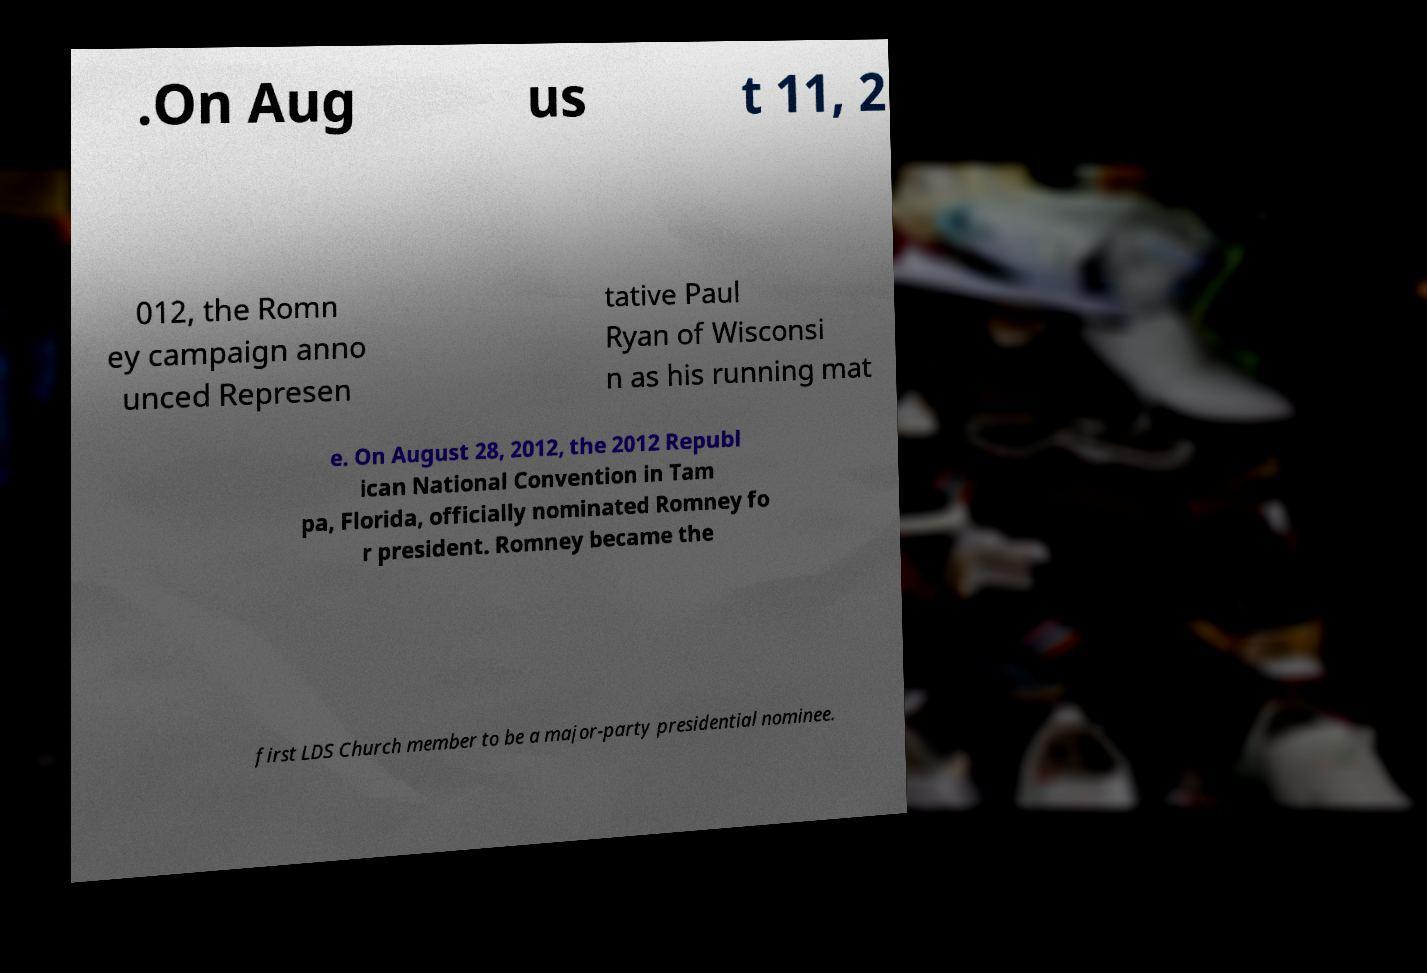Please identify and transcribe the text found in this image. .On Aug us t 11, 2 012, the Romn ey campaign anno unced Represen tative Paul Ryan of Wisconsi n as his running mat e. On August 28, 2012, the 2012 Republ ican National Convention in Tam pa, Florida, officially nominated Romney fo r president. Romney became the first LDS Church member to be a major-party presidential nominee. 